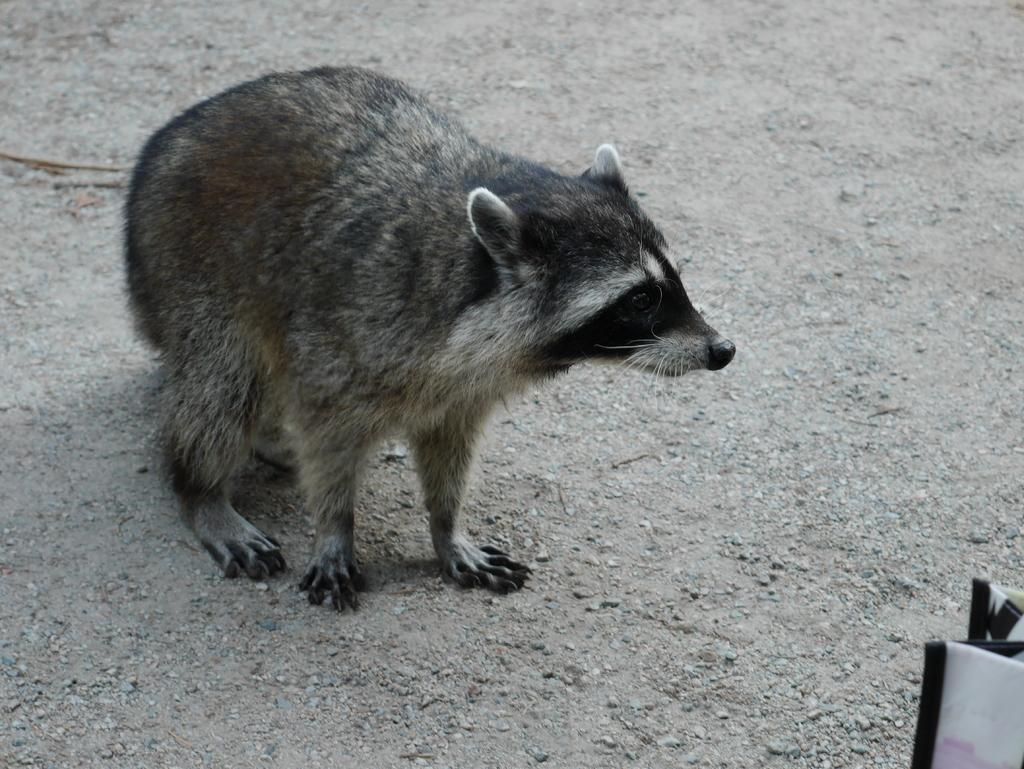What type of animal is in the image? There is a grey-colored raccoon in the image. Where is the raccoon located? The raccoon is on the ground. What is the color of the white-colored object in the image? The white-colored object in the image is white. How many sheep are visible in the image? There are no sheep present in the image. What type of tin is being used by the raccoon in the image? There is no tin present in the image, and the raccoon is not using any object. 